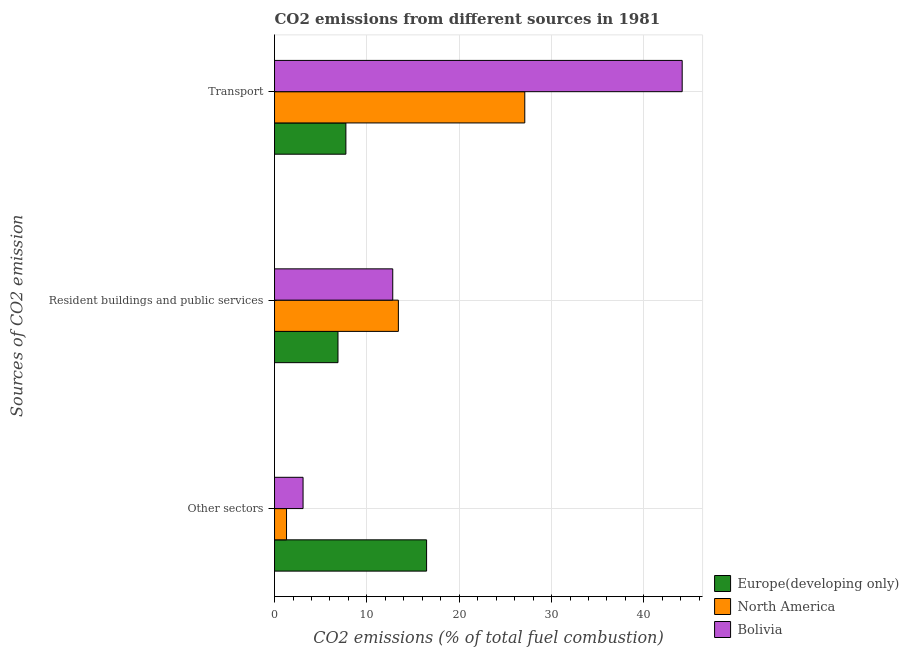How many groups of bars are there?
Your response must be concise. 3. What is the label of the 1st group of bars from the top?
Ensure brevity in your answer.  Transport. What is the percentage of co2 emissions from other sectors in Europe(developing only)?
Give a very brief answer. 16.47. Across all countries, what is the maximum percentage of co2 emissions from other sectors?
Offer a terse response. 16.47. Across all countries, what is the minimum percentage of co2 emissions from transport?
Your answer should be compact. 7.73. What is the total percentage of co2 emissions from other sectors in the graph?
Offer a terse response. 20.86. What is the difference between the percentage of co2 emissions from other sectors in Europe(developing only) and that in North America?
Offer a terse response. 15.17. What is the difference between the percentage of co2 emissions from transport in North America and the percentage of co2 emissions from other sectors in Europe(developing only)?
Provide a succinct answer. 10.63. What is the average percentage of co2 emissions from resident buildings and public services per country?
Your answer should be compact. 11.03. What is the difference between the percentage of co2 emissions from resident buildings and public services and percentage of co2 emissions from transport in Bolivia?
Ensure brevity in your answer.  -31.35. In how many countries, is the percentage of co2 emissions from other sectors greater than 12 %?
Keep it short and to the point. 1. What is the ratio of the percentage of co2 emissions from resident buildings and public services in Europe(developing only) to that in North America?
Your answer should be very brief. 0.51. Is the percentage of co2 emissions from other sectors in Bolivia less than that in North America?
Your answer should be compact. No. Is the difference between the percentage of co2 emissions from other sectors in Bolivia and North America greater than the difference between the percentage of co2 emissions from transport in Bolivia and North America?
Your answer should be compact. No. What is the difference between the highest and the second highest percentage of co2 emissions from transport?
Ensure brevity in your answer.  17.05. What is the difference between the highest and the lowest percentage of co2 emissions from transport?
Offer a very short reply. 36.42. In how many countries, is the percentage of co2 emissions from transport greater than the average percentage of co2 emissions from transport taken over all countries?
Your answer should be very brief. 2. Is the sum of the percentage of co2 emissions from resident buildings and public services in North America and Europe(developing only) greater than the maximum percentage of co2 emissions from other sectors across all countries?
Your response must be concise. Yes. What does the 3rd bar from the top in Resident buildings and public services represents?
Offer a very short reply. Europe(developing only). How many legend labels are there?
Your response must be concise. 3. How are the legend labels stacked?
Give a very brief answer. Vertical. What is the title of the graph?
Ensure brevity in your answer.  CO2 emissions from different sources in 1981. What is the label or title of the X-axis?
Your answer should be compact. CO2 emissions (% of total fuel combustion). What is the label or title of the Y-axis?
Give a very brief answer. Sources of CO2 emission. What is the CO2 emissions (% of total fuel combustion) in Europe(developing only) in Other sectors?
Provide a succinct answer. 16.47. What is the CO2 emissions (% of total fuel combustion) in North America in Other sectors?
Your answer should be very brief. 1.3. What is the CO2 emissions (% of total fuel combustion) of Bolivia in Other sectors?
Ensure brevity in your answer.  3.09. What is the CO2 emissions (% of total fuel combustion) of Europe(developing only) in Resident buildings and public services?
Keep it short and to the point. 6.87. What is the CO2 emissions (% of total fuel combustion) in North America in Resident buildings and public services?
Keep it short and to the point. 13.41. What is the CO2 emissions (% of total fuel combustion) of Bolivia in Resident buildings and public services?
Your response must be concise. 12.8. What is the CO2 emissions (% of total fuel combustion) in Europe(developing only) in Transport?
Make the answer very short. 7.73. What is the CO2 emissions (% of total fuel combustion) in North America in Transport?
Keep it short and to the point. 27.1. What is the CO2 emissions (% of total fuel combustion) of Bolivia in Transport?
Your response must be concise. 44.15. Across all Sources of CO2 emission, what is the maximum CO2 emissions (% of total fuel combustion) of Europe(developing only)?
Provide a short and direct response. 16.47. Across all Sources of CO2 emission, what is the maximum CO2 emissions (% of total fuel combustion) of North America?
Your answer should be very brief. 27.1. Across all Sources of CO2 emission, what is the maximum CO2 emissions (% of total fuel combustion) in Bolivia?
Keep it short and to the point. 44.15. Across all Sources of CO2 emission, what is the minimum CO2 emissions (% of total fuel combustion) in Europe(developing only)?
Make the answer very short. 6.87. Across all Sources of CO2 emission, what is the minimum CO2 emissions (% of total fuel combustion) in North America?
Your answer should be very brief. 1.3. Across all Sources of CO2 emission, what is the minimum CO2 emissions (% of total fuel combustion) of Bolivia?
Provide a succinct answer. 3.09. What is the total CO2 emissions (% of total fuel combustion) in Europe(developing only) in the graph?
Give a very brief answer. 31.07. What is the total CO2 emissions (% of total fuel combustion) in North America in the graph?
Offer a very short reply. 41.81. What is the total CO2 emissions (% of total fuel combustion) of Bolivia in the graph?
Keep it short and to the point. 60.04. What is the difference between the CO2 emissions (% of total fuel combustion) of Europe(developing only) in Other sectors and that in Resident buildings and public services?
Your answer should be compact. 9.6. What is the difference between the CO2 emissions (% of total fuel combustion) in North America in Other sectors and that in Resident buildings and public services?
Offer a very short reply. -12.11. What is the difference between the CO2 emissions (% of total fuel combustion) in Bolivia in Other sectors and that in Resident buildings and public services?
Your answer should be compact. -9.71. What is the difference between the CO2 emissions (% of total fuel combustion) of Europe(developing only) in Other sectors and that in Transport?
Make the answer very short. 8.74. What is the difference between the CO2 emissions (% of total fuel combustion) in North America in Other sectors and that in Transport?
Provide a short and direct response. -25.8. What is the difference between the CO2 emissions (% of total fuel combustion) in Bolivia in Other sectors and that in Transport?
Your response must be concise. -41.06. What is the difference between the CO2 emissions (% of total fuel combustion) of Europe(developing only) in Resident buildings and public services and that in Transport?
Offer a very short reply. -0.86. What is the difference between the CO2 emissions (% of total fuel combustion) in North America in Resident buildings and public services and that in Transport?
Provide a short and direct response. -13.69. What is the difference between the CO2 emissions (% of total fuel combustion) of Bolivia in Resident buildings and public services and that in Transport?
Your answer should be very brief. -31.35. What is the difference between the CO2 emissions (% of total fuel combustion) of Europe(developing only) in Other sectors and the CO2 emissions (% of total fuel combustion) of North America in Resident buildings and public services?
Your answer should be very brief. 3.06. What is the difference between the CO2 emissions (% of total fuel combustion) of Europe(developing only) in Other sectors and the CO2 emissions (% of total fuel combustion) of Bolivia in Resident buildings and public services?
Ensure brevity in your answer.  3.66. What is the difference between the CO2 emissions (% of total fuel combustion) in North America in Other sectors and the CO2 emissions (% of total fuel combustion) in Bolivia in Resident buildings and public services?
Offer a terse response. -11.5. What is the difference between the CO2 emissions (% of total fuel combustion) in Europe(developing only) in Other sectors and the CO2 emissions (% of total fuel combustion) in North America in Transport?
Your answer should be very brief. -10.63. What is the difference between the CO2 emissions (% of total fuel combustion) in Europe(developing only) in Other sectors and the CO2 emissions (% of total fuel combustion) in Bolivia in Transport?
Provide a succinct answer. -27.68. What is the difference between the CO2 emissions (% of total fuel combustion) in North America in Other sectors and the CO2 emissions (% of total fuel combustion) in Bolivia in Transport?
Keep it short and to the point. -42.85. What is the difference between the CO2 emissions (% of total fuel combustion) of Europe(developing only) in Resident buildings and public services and the CO2 emissions (% of total fuel combustion) of North America in Transport?
Ensure brevity in your answer.  -20.23. What is the difference between the CO2 emissions (% of total fuel combustion) of Europe(developing only) in Resident buildings and public services and the CO2 emissions (% of total fuel combustion) of Bolivia in Transport?
Ensure brevity in your answer.  -37.28. What is the difference between the CO2 emissions (% of total fuel combustion) of North America in Resident buildings and public services and the CO2 emissions (% of total fuel combustion) of Bolivia in Transport?
Provide a succinct answer. -30.74. What is the average CO2 emissions (% of total fuel combustion) of Europe(developing only) per Sources of CO2 emission?
Your answer should be compact. 10.36. What is the average CO2 emissions (% of total fuel combustion) of North America per Sources of CO2 emission?
Ensure brevity in your answer.  13.94. What is the average CO2 emissions (% of total fuel combustion) of Bolivia per Sources of CO2 emission?
Keep it short and to the point. 20.01. What is the difference between the CO2 emissions (% of total fuel combustion) of Europe(developing only) and CO2 emissions (% of total fuel combustion) of North America in Other sectors?
Your answer should be very brief. 15.17. What is the difference between the CO2 emissions (% of total fuel combustion) of Europe(developing only) and CO2 emissions (% of total fuel combustion) of Bolivia in Other sectors?
Your response must be concise. 13.38. What is the difference between the CO2 emissions (% of total fuel combustion) in North America and CO2 emissions (% of total fuel combustion) in Bolivia in Other sectors?
Your response must be concise. -1.79. What is the difference between the CO2 emissions (% of total fuel combustion) in Europe(developing only) and CO2 emissions (% of total fuel combustion) in North America in Resident buildings and public services?
Offer a very short reply. -6.54. What is the difference between the CO2 emissions (% of total fuel combustion) in Europe(developing only) and CO2 emissions (% of total fuel combustion) in Bolivia in Resident buildings and public services?
Your response must be concise. -5.93. What is the difference between the CO2 emissions (% of total fuel combustion) in North America and CO2 emissions (% of total fuel combustion) in Bolivia in Resident buildings and public services?
Provide a short and direct response. 0.61. What is the difference between the CO2 emissions (% of total fuel combustion) of Europe(developing only) and CO2 emissions (% of total fuel combustion) of North America in Transport?
Your response must be concise. -19.37. What is the difference between the CO2 emissions (% of total fuel combustion) in Europe(developing only) and CO2 emissions (% of total fuel combustion) in Bolivia in Transport?
Your answer should be very brief. -36.42. What is the difference between the CO2 emissions (% of total fuel combustion) in North America and CO2 emissions (% of total fuel combustion) in Bolivia in Transport?
Give a very brief answer. -17.05. What is the ratio of the CO2 emissions (% of total fuel combustion) in Europe(developing only) in Other sectors to that in Resident buildings and public services?
Make the answer very short. 2.4. What is the ratio of the CO2 emissions (% of total fuel combustion) of North America in Other sectors to that in Resident buildings and public services?
Provide a succinct answer. 0.1. What is the ratio of the CO2 emissions (% of total fuel combustion) of Bolivia in Other sectors to that in Resident buildings and public services?
Give a very brief answer. 0.24. What is the ratio of the CO2 emissions (% of total fuel combustion) of Europe(developing only) in Other sectors to that in Transport?
Your answer should be compact. 2.13. What is the ratio of the CO2 emissions (% of total fuel combustion) in North America in Other sectors to that in Transport?
Keep it short and to the point. 0.05. What is the ratio of the CO2 emissions (% of total fuel combustion) in Bolivia in Other sectors to that in Transport?
Make the answer very short. 0.07. What is the ratio of the CO2 emissions (% of total fuel combustion) of Europe(developing only) in Resident buildings and public services to that in Transport?
Make the answer very short. 0.89. What is the ratio of the CO2 emissions (% of total fuel combustion) of North America in Resident buildings and public services to that in Transport?
Offer a terse response. 0.49. What is the ratio of the CO2 emissions (% of total fuel combustion) in Bolivia in Resident buildings and public services to that in Transport?
Make the answer very short. 0.29. What is the difference between the highest and the second highest CO2 emissions (% of total fuel combustion) in Europe(developing only)?
Your answer should be compact. 8.74. What is the difference between the highest and the second highest CO2 emissions (% of total fuel combustion) in North America?
Your response must be concise. 13.69. What is the difference between the highest and the second highest CO2 emissions (% of total fuel combustion) in Bolivia?
Your answer should be compact. 31.35. What is the difference between the highest and the lowest CO2 emissions (% of total fuel combustion) in Europe(developing only)?
Your answer should be compact. 9.6. What is the difference between the highest and the lowest CO2 emissions (% of total fuel combustion) in North America?
Ensure brevity in your answer.  25.8. What is the difference between the highest and the lowest CO2 emissions (% of total fuel combustion) in Bolivia?
Offer a very short reply. 41.06. 